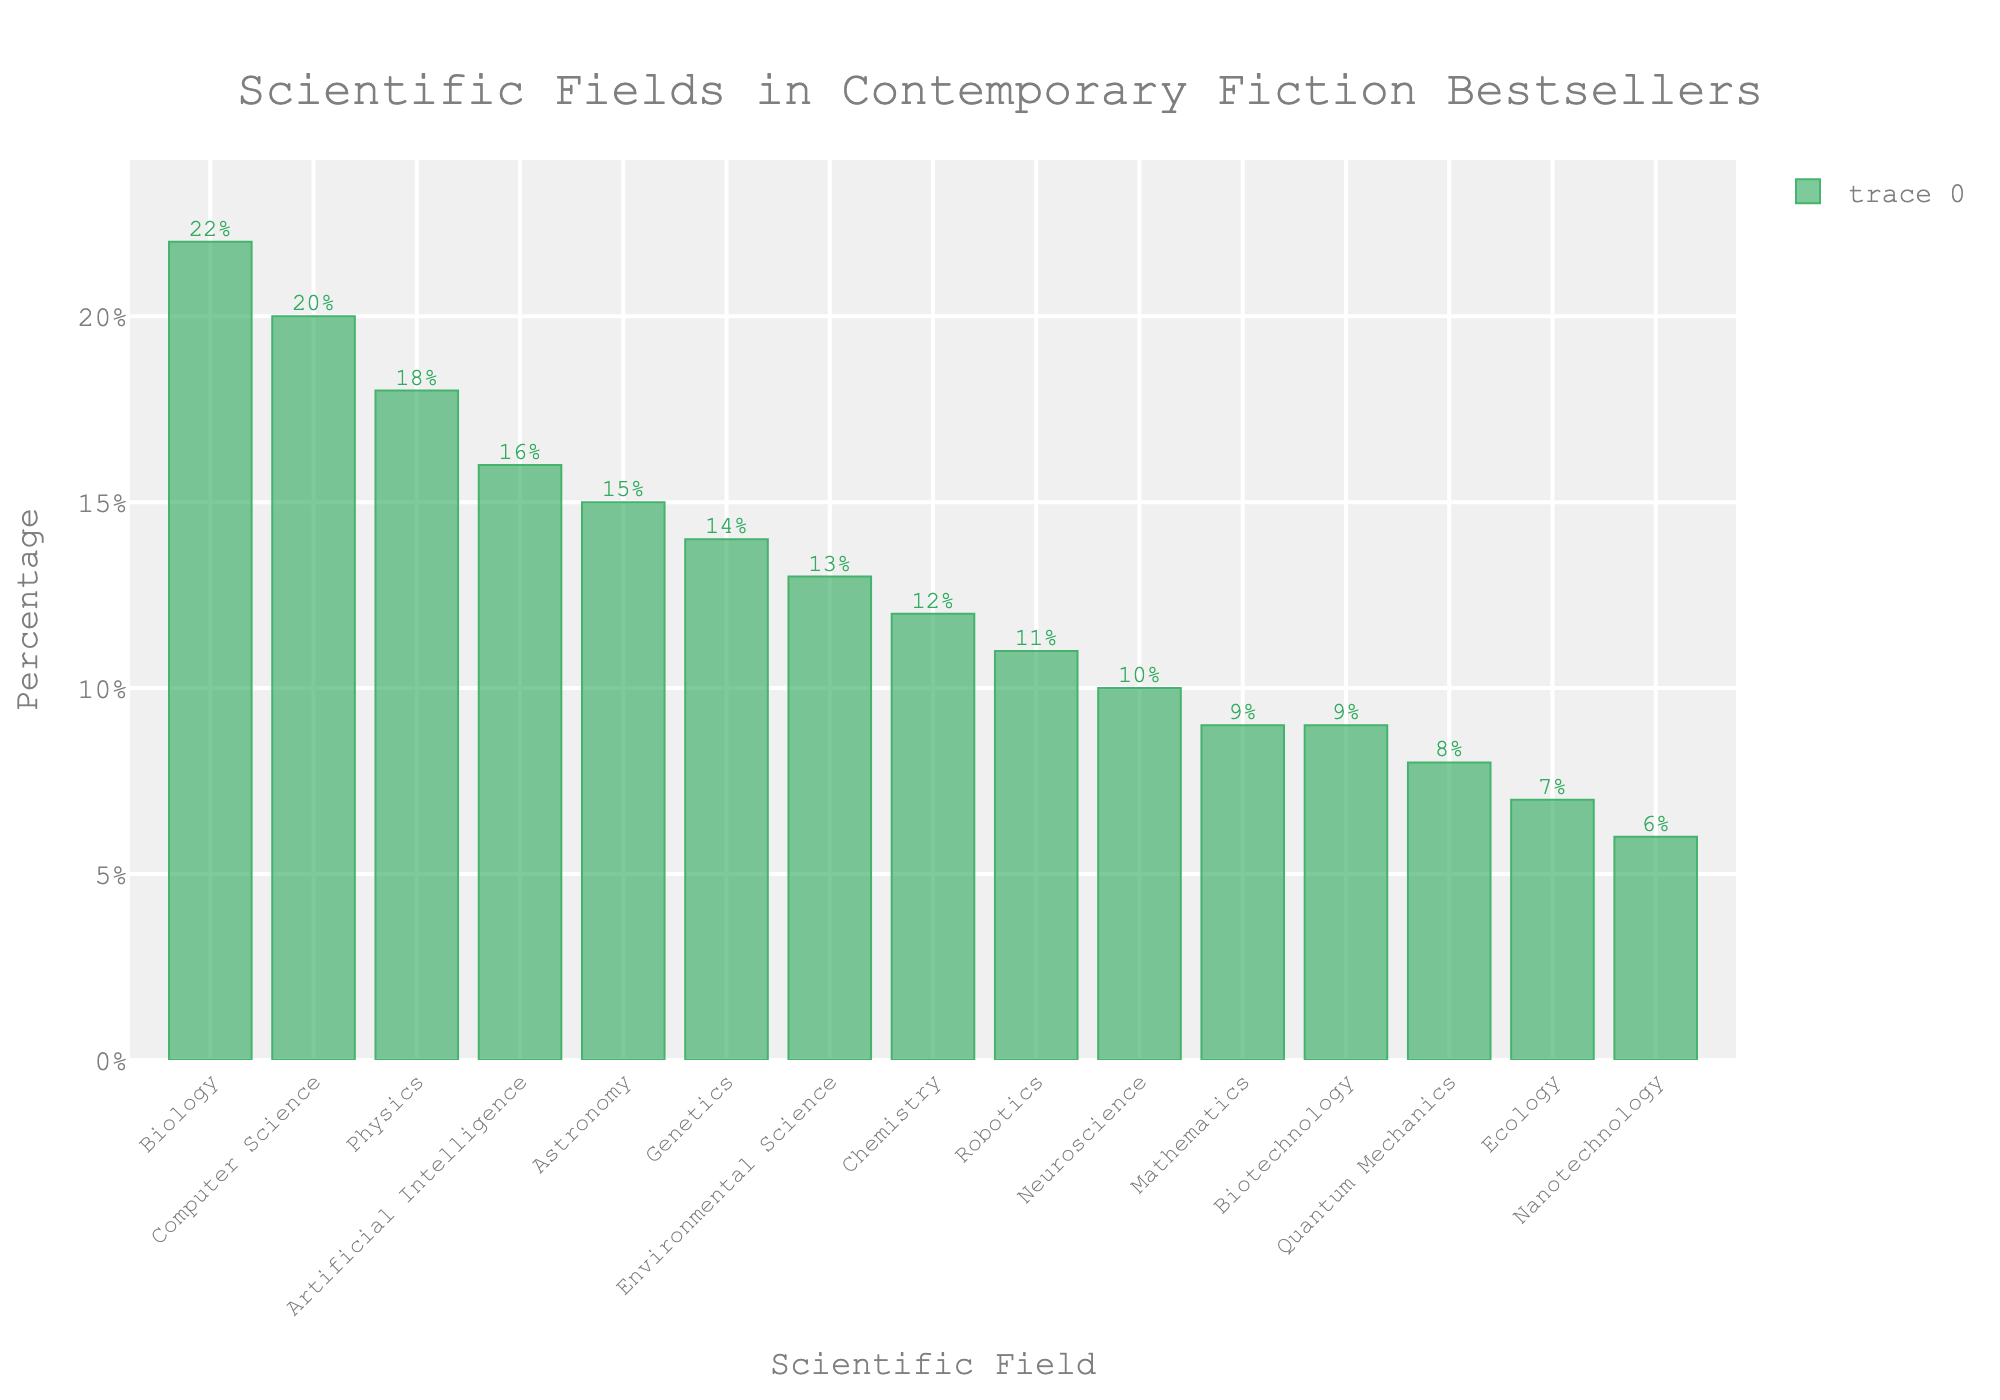what is the sum of the percentages for Biology and Computer Science? Find the bars labeled "Biology" and "Computer Science" and note their percentages (22% and 20% respectively). Add them together to get the sum: 22 + 20 = 42%
Answer: 42% What is the field with the lowest representation? Identify the shortest bar in the bar chart. The shortest bar corresponds to the field "Nanotechnology" with a representation of 6%
Answer: Nanotechnology How much higher is Biology's percentage compared to Neuroscience? Note the percentages for Biology and Neuroscience (22% and 10% respectively). Subtract Neuroscience's percentage from Biology's percentage: 22 - 10 = 12%
Answer: 12% Are there more fields with a representation of 10% or less than those with more than 10%? Count the fields with percentages of 10% or less (Neuroscience, Quantum Mechanics, Ecology, Nanotechnology, Biotechnology, Mathematics - 6 fields). Then, count the fields with percentages more than 10% (Physics, Biology, Chemistry, Astronomy, Genetics, Computer Science, Environmental Science, Robotics, Artificial Intelligence - 9 fields). Compare the two counts.
Answer: No What is the average percentage for Physics, Chemistry, and Quantum Mechanics? Note the percentages for Physics, Chemistry, and Quantum Mechanics (18%, 12%, and 8% respectively). Calculate the average: (18 + 12 + 8) / 3 = 12.67%
Answer: 12.67% Which field has a higher percentage, Artificial Intelligence or Genetics? Compare the heights of the bars labeled "Artificial Intelligence" and "Genetics." Artificial Intelligence has a percentage of 16% whereas Genetics has 14%. So, Artificial Intelligence has a higher percentage.
Answer: Artificial Intelligence Is the percentage for Environmental Science closer to that of Robotics or of Biology? Note down the percentages for Environmental Science (13%), Robotics (11%), and Biology (22%). Find the absolute difference:
Answer: Environmental Science is closer to Robotics How much is the combined representation of Physics, Astronomy, and Chemistry? Add the percentages for Physics (18%), Astronomy (15%), and Chemistry (12%). The sum is 18 + 15 + 12 = 45%
Answer: 45% Which field has exactly 10% representation? Identify the bar that corresponds to 10%. The field with a bar at 10% is Neuroscience.
Answer: Neuroscience What is the median percentage among all fields shown? List all percentages in ascending order: 6, 7, 8, 9, 9, 10, 11, 12, 13, 14, 15, 16, 18, 20, 22. The middle value (8th position) in this list is 12%
Answer: 12% 